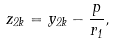<formula> <loc_0><loc_0><loc_500><loc_500>z _ { 2 k } = y _ { 2 k } - \frac { p } { r _ { 1 } } ,</formula> 